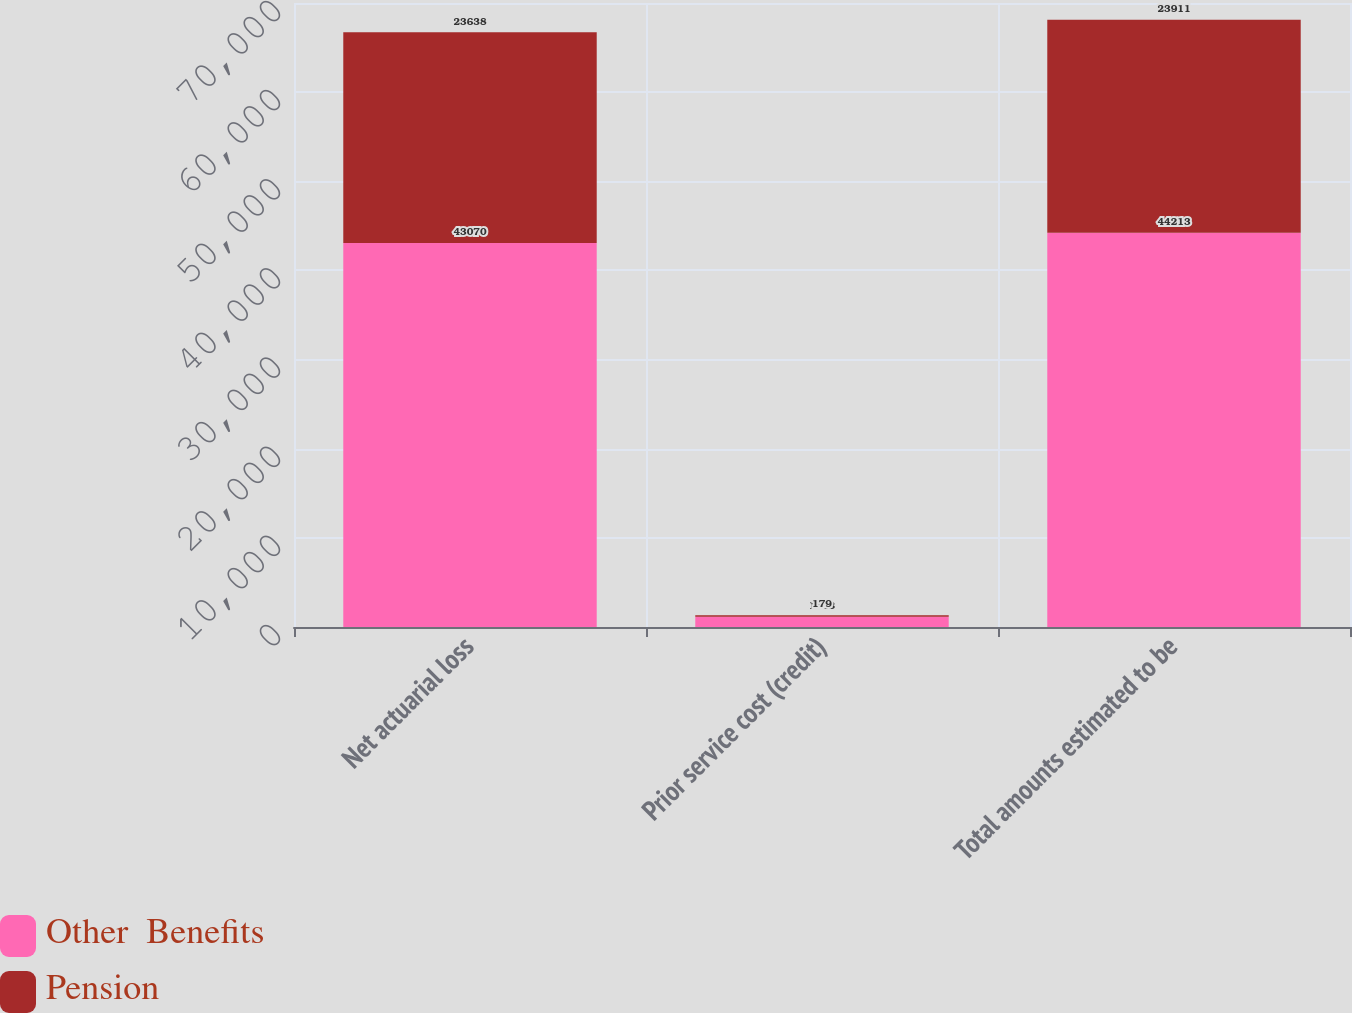Convert chart to OTSL. <chart><loc_0><loc_0><loc_500><loc_500><stacked_bar_chart><ecel><fcel>Net actuarial loss<fcel>Prior service cost (credit)<fcel>Total amounts estimated to be<nl><fcel>Other  Benefits<fcel>43070<fcel>1143<fcel>44213<nl><fcel>Pension<fcel>23638<fcel>179<fcel>23911<nl></chart> 